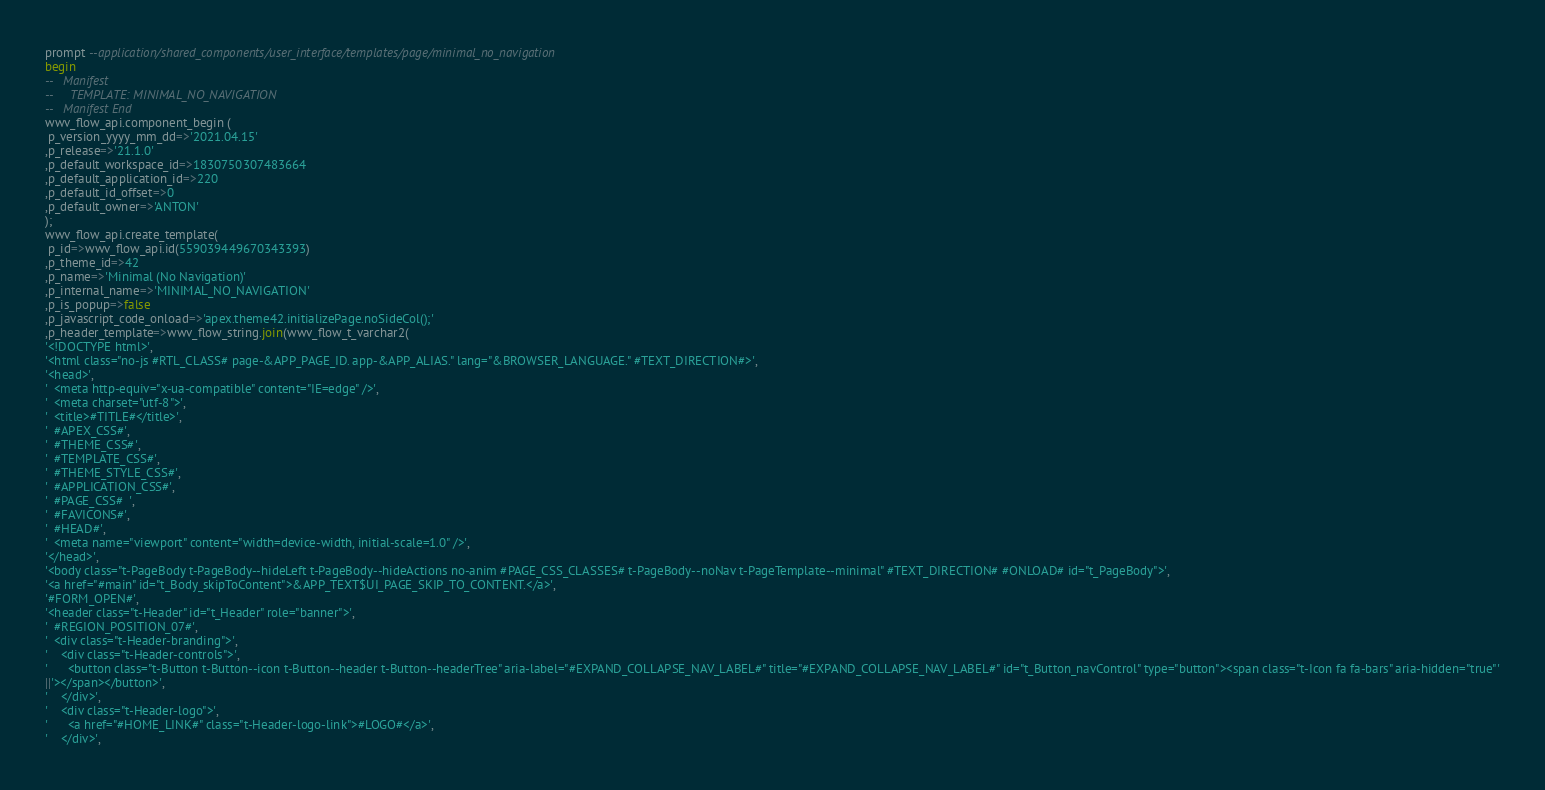Convert code to text. <code><loc_0><loc_0><loc_500><loc_500><_SQL_>prompt --application/shared_components/user_interface/templates/page/minimal_no_navigation
begin
--   Manifest
--     TEMPLATE: MINIMAL_NO_NAVIGATION
--   Manifest End
wwv_flow_api.component_begin (
 p_version_yyyy_mm_dd=>'2021.04.15'
,p_release=>'21.1.0'
,p_default_workspace_id=>1830750307483664
,p_default_application_id=>220
,p_default_id_offset=>0
,p_default_owner=>'ANTON'
);
wwv_flow_api.create_template(
 p_id=>wwv_flow_api.id(559039449670343393)
,p_theme_id=>42
,p_name=>'Minimal (No Navigation)'
,p_internal_name=>'MINIMAL_NO_NAVIGATION'
,p_is_popup=>false
,p_javascript_code_onload=>'apex.theme42.initializePage.noSideCol();'
,p_header_template=>wwv_flow_string.join(wwv_flow_t_varchar2(
'<!DOCTYPE html>',
'<html class="no-js #RTL_CLASS# page-&APP_PAGE_ID. app-&APP_ALIAS." lang="&BROWSER_LANGUAGE." #TEXT_DIRECTION#>',
'<head>',
'  <meta http-equiv="x-ua-compatible" content="IE=edge" />',
'  <meta charset="utf-8">',
'  <title>#TITLE#</title>',
'  #APEX_CSS#',
'  #THEME_CSS#',
'  #TEMPLATE_CSS#',
'  #THEME_STYLE_CSS#',
'  #APPLICATION_CSS#',
'  #PAGE_CSS#  ',
'  #FAVICONS#',
'  #HEAD#',
'  <meta name="viewport" content="width=device-width, initial-scale=1.0" />',
'</head>',
'<body class="t-PageBody t-PageBody--hideLeft t-PageBody--hideActions no-anim #PAGE_CSS_CLASSES# t-PageBody--noNav t-PageTemplate--minimal" #TEXT_DIRECTION# #ONLOAD# id="t_PageBody">',
'<a href="#main" id="t_Body_skipToContent">&APP_TEXT$UI_PAGE_SKIP_TO_CONTENT.</a>',
'#FORM_OPEN#',
'<header class="t-Header" id="t_Header" role="banner">',
'  #REGION_POSITION_07#',
'  <div class="t-Header-branding">',
'    <div class="t-Header-controls">',
'      <button class="t-Button t-Button--icon t-Button--header t-Button--headerTree" aria-label="#EXPAND_COLLAPSE_NAV_LABEL#" title="#EXPAND_COLLAPSE_NAV_LABEL#" id="t_Button_navControl" type="button"><span class="t-Icon fa fa-bars" aria-hidden="true"'
||'></span></button>',
'    </div>',
'    <div class="t-Header-logo">',
'      <a href="#HOME_LINK#" class="t-Header-logo-link">#LOGO#</a>',
'    </div>',</code> 